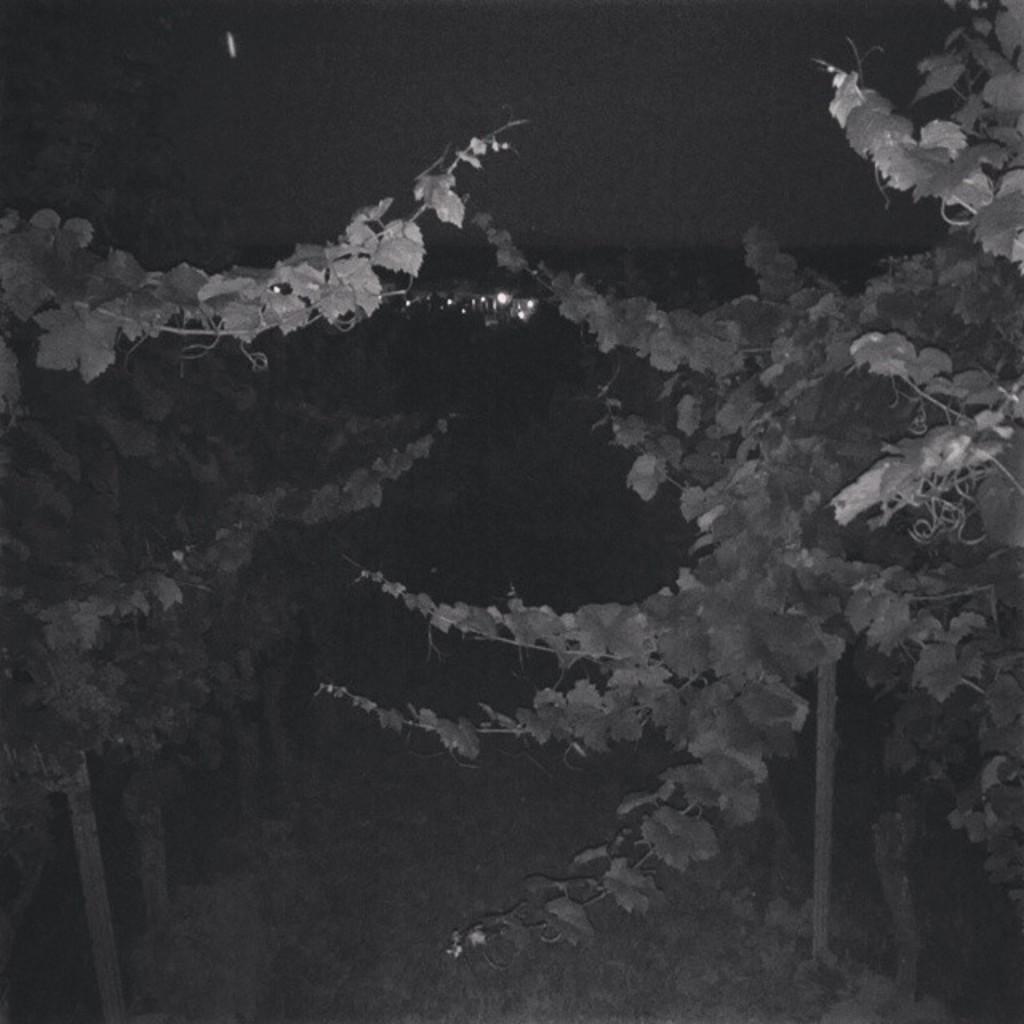In one or two sentences, can you explain what this image depicts? In this image I can see the dark picture in which I can see few trees, some grass on the ground and few lights. In the background I can see the sky. 